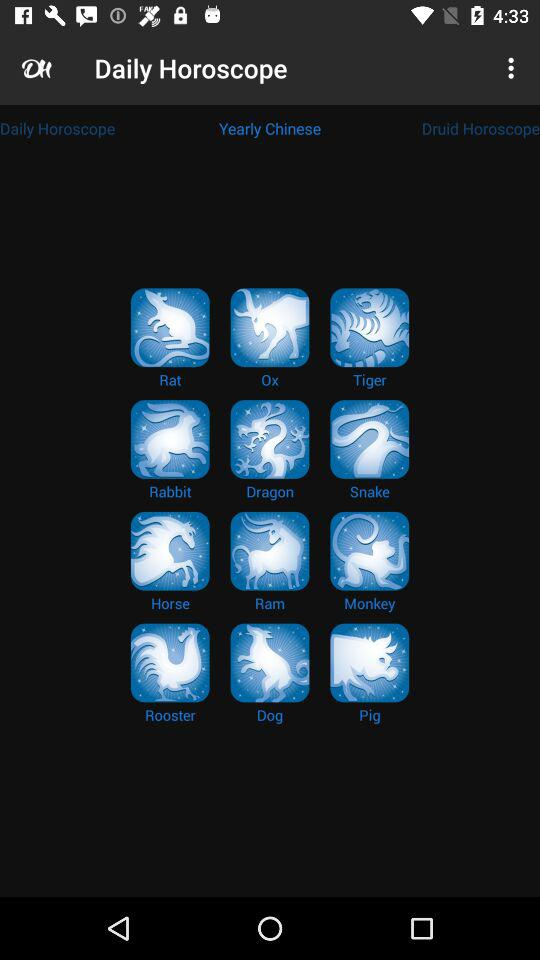How many animals are there in the Zodiac?
Answer the question using a single word or phrase. 12 